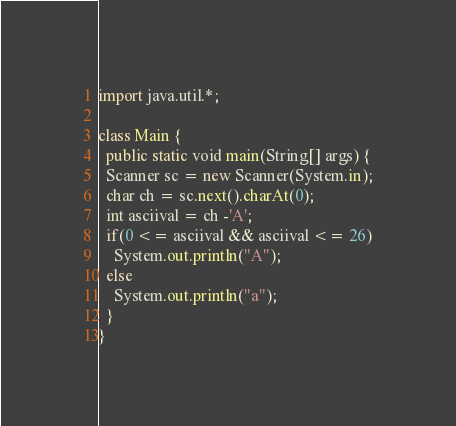Convert code to text. <code><loc_0><loc_0><loc_500><loc_500><_Java_>import java.util.*;

class Main {
  public static void main(String[] args) {
  Scanner sc = new Scanner(System.in);
  char ch = sc.next().charAt(0);
  int asciival = ch -'A';
  if(0 <= asciival && asciival <= 26)
    System.out.println("A");
  else
    System.out.println("a");
  }
}
</code> 